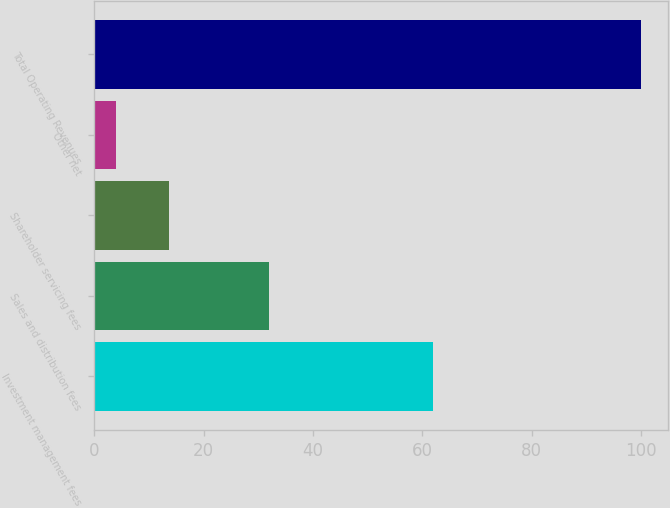Convert chart to OTSL. <chart><loc_0><loc_0><loc_500><loc_500><bar_chart><fcel>Investment management fees<fcel>Sales and distribution fees<fcel>Shareholder servicing fees<fcel>Other net<fcel>Total Operating Revenues<nl><fcel>62<fcel>32<fcel>13.63<fcel>4.03<fcel>100<nl></chart> 